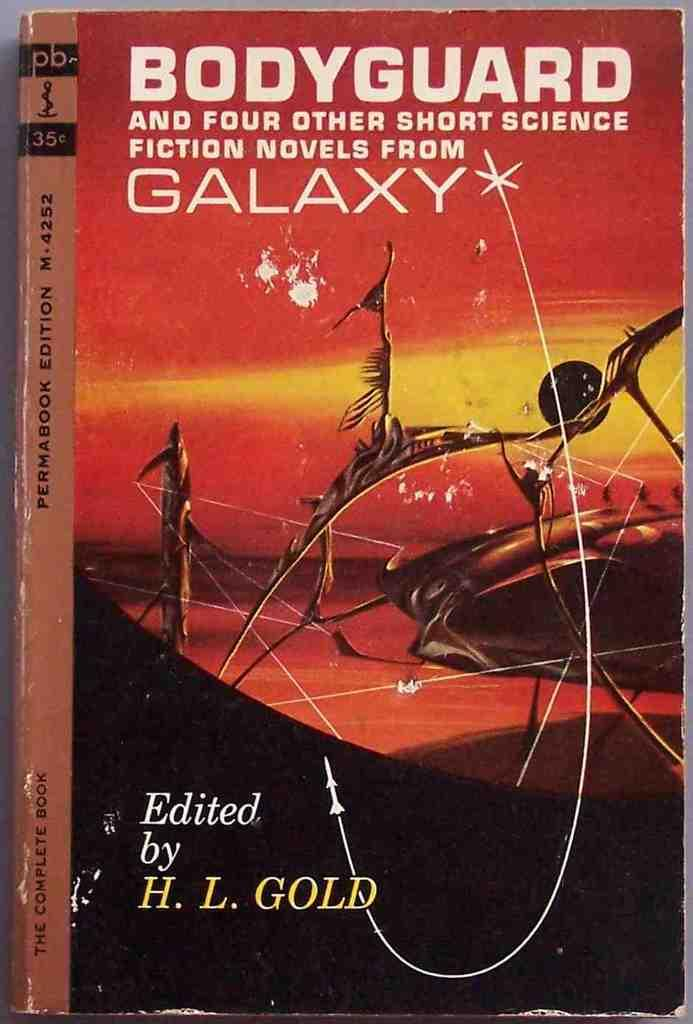<image>
Offer a succinct explanation of the picture presented. A book called Bodyguard and four other short science fiction novels from galaxy. 